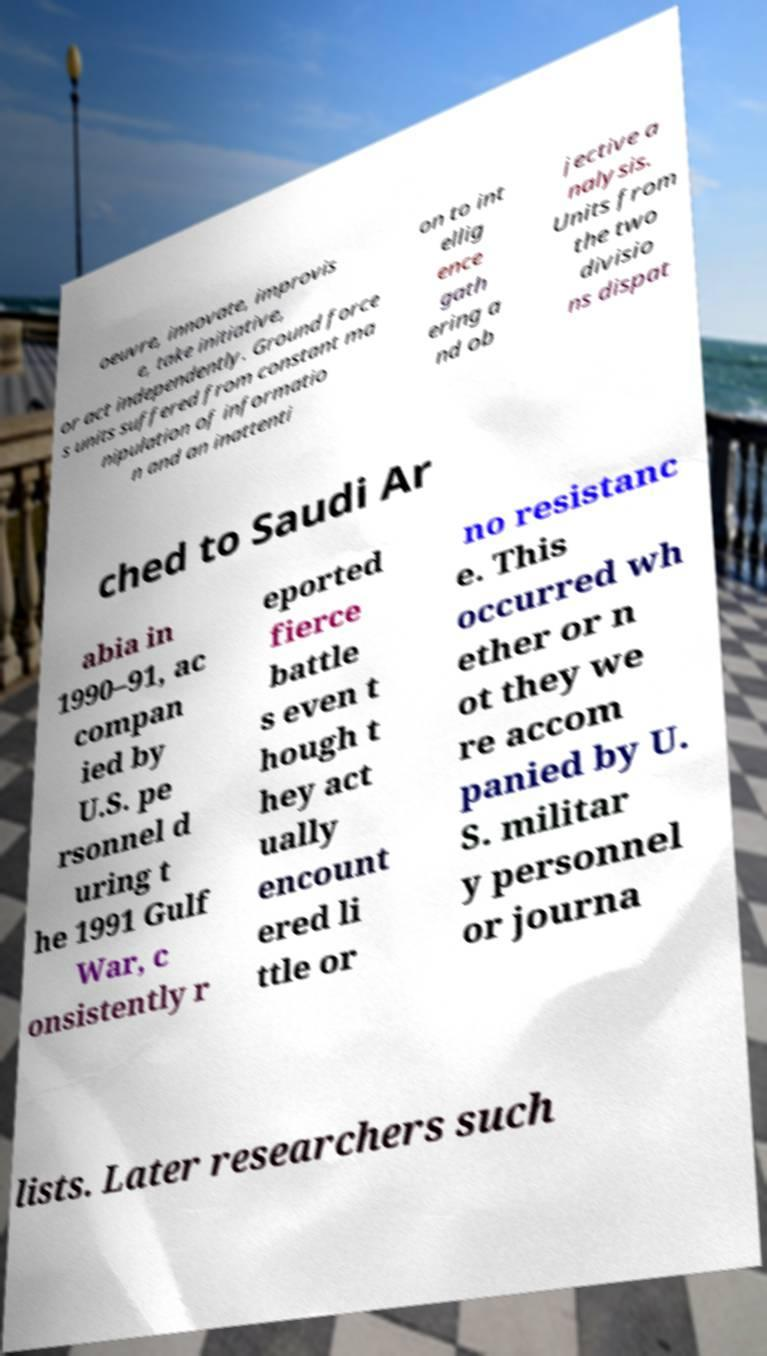What messages or text are displayed in this image? I need them in a readable, typed format. oeuvre, innovate, improvis e, take initiative, or act independently. Ground force s units suffered from constant ma nipulation of informatio n and an inattenti on to int ellig ence gath ering a nd ob jective a nalysis. Units from the two divisio ns dispat ched to Saudi Ar abia in 1990–91, ac compan ied by U.S. pe rsonnel d uring t he 1991 Gulf War, c onsistently r eported fierce battle s even t hough t hey act ually encount ered li ttle or no resistanc e. This occurred wh ether or n ot they we re accom panied by U. S. militar y personnel or journa lists. Later researchers such 